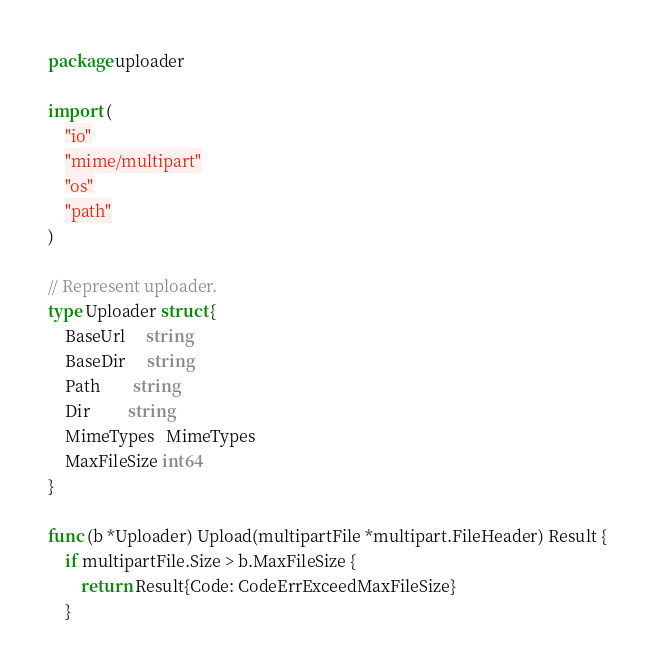Convert code to text. <code><loc_0><loc_0><loc_500><loc_500><_Go_>package uploader

import (
	"io"
	"mime/multipart"
	"os"
	"path"
)

// Represent uploader.
type Uploader struct {
	BaseUrl     string
	BaseDir     string
	Path        string
	Dir         string
	MimeTypes   MimeTypes
	MaxFileSize int64
}

func (b *Uploader) Upload(multipartFile *multipart.FileHeader) Result {
	if multipartFile.Size > b.MaxFileSize {
		return Result{Code: CodeErrExceedMaxFileSize}
	}
</code> 